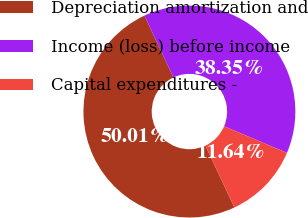<chart> <loc_0><loc_0><loc_500><loc_500><pie_chart><fcel>Depreciation amortization and<fcel>Income (loss) before income<fcel>Capital expenditures -<nl><fcel>50.01%<fcel>38.35%<fcel>11.64%<nl></chart> 